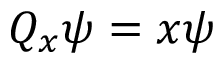<formula> <loc_0><loc_0><loc_500><loc_500>Q _ { x } \psi = x \psi</formula> 